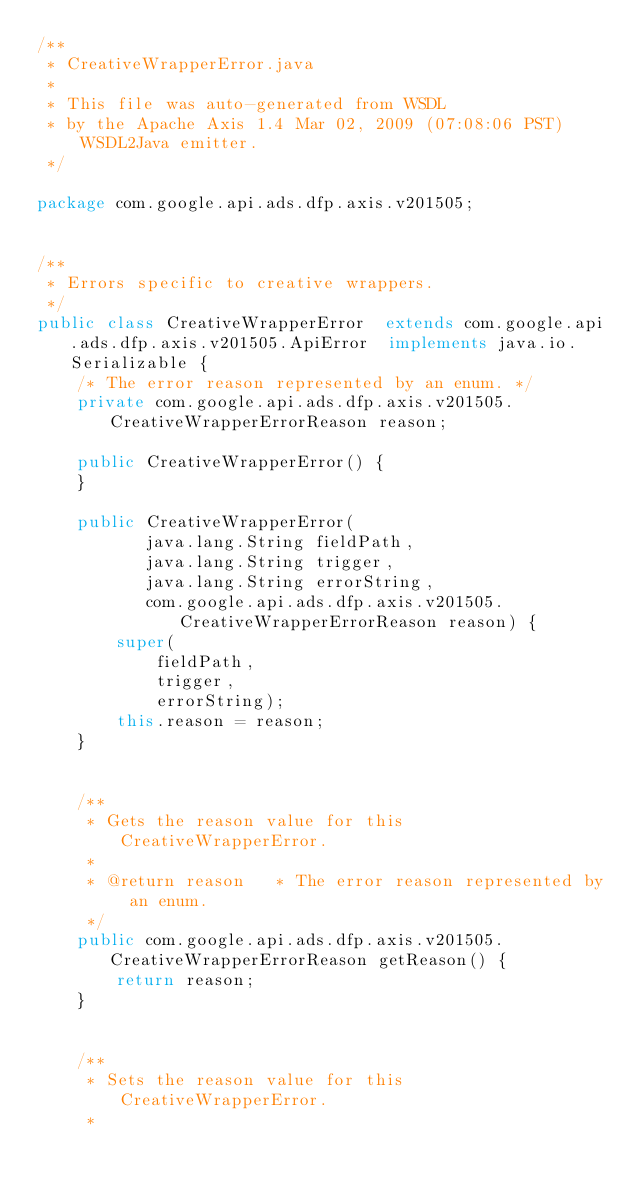<code> <loc_0><loc_0><loc_500><loc_500><_Java_>/**
 * CreativeWrapperError.java
 *
 * This file was auto-generated from WSDL
 * by the Apache Axis 1.4 Mar 02, 2009 (07:08:06 PST) WSDL2Java emitter.
 */

package com.google.api.ads.dfp.axis.v201505;


/**
 * Errors specific to creative wrappers.
 */
public class CreativeWrapperError  extends com.google.api.ads.dfp.axis.v201505.ApiError  implements java.io.Serializable {
    /* The error reason represented by an enum. */
    private com.google.api.ads.dfp.axis.v201505.CreativeWrapperErrorReason reason;

    public CreativeWrapperError() {
    }

    public CreativeWrapperError(
           java.lang.String fieldPath,
           java.lang.String trigger,
           java.lang.String errorString,
           com.google.api.ads.dfp.axis.v201505.CreativeWrapperErrorReason reason) {
        super(
            fieldPath,
            trigger,
            errorString);
        this.reason = reason;
    }


    /**
     * Gets the reason value for this CreativeWrapperError.
     * 
     * @return reason   * The error reason represented by an enum.
     */
    public com.google.api.ads.dfp.axis.v201505.CreativeWrapperErrorReason getReason() {
        return reason;
    }


    /**
     * Sets the reason value for this CreativeWrapperError.
     * </code> 